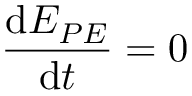<formula> <loc_0><loc_0><loc_500><loc_500>\frac { d E _ { P E } } { d t } = 0</formula> 